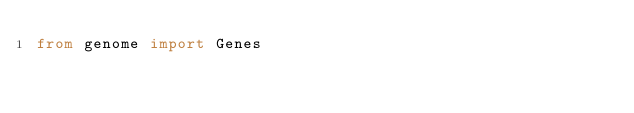<code> <loc_0><loc_0><loc_500><loc_500><_Python_>from genome import Genes

</code> 